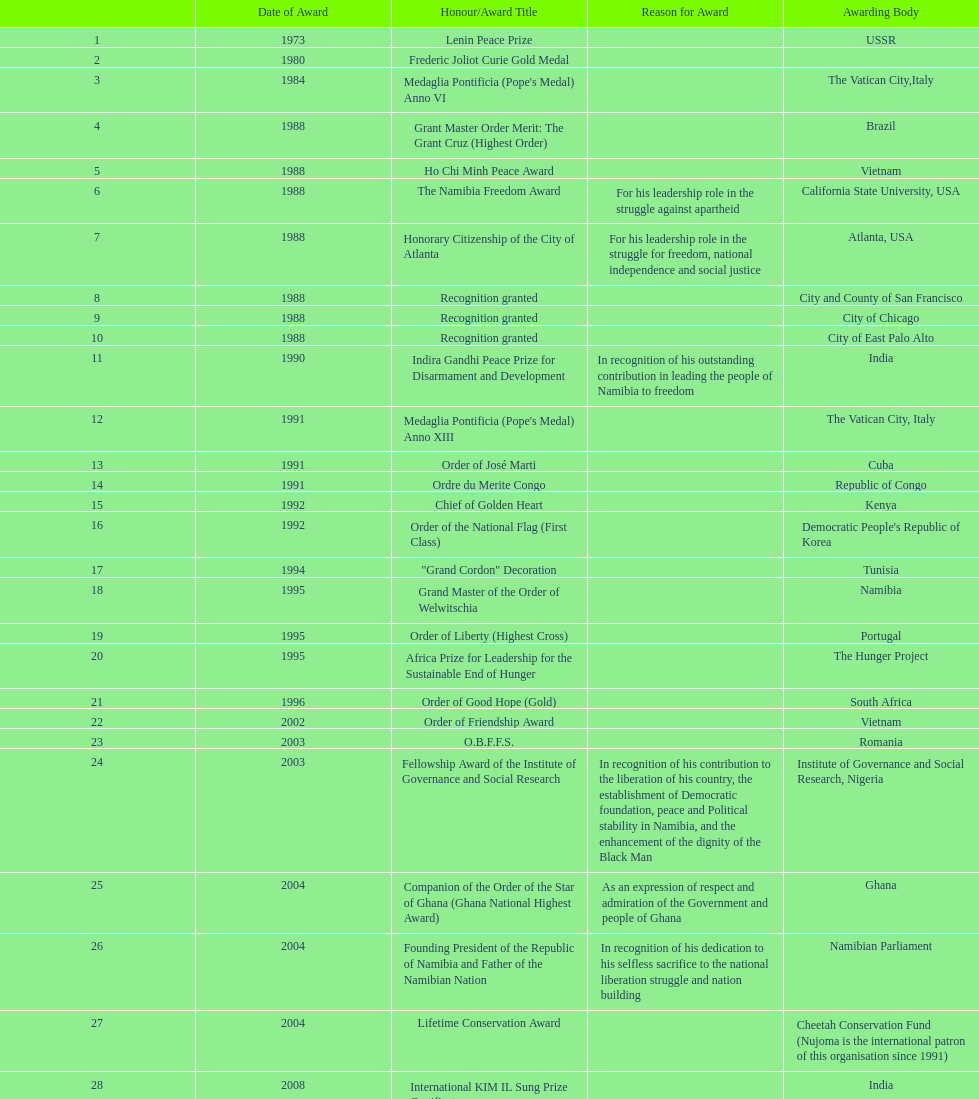In which year were the most accolades/award titles bestowed? 1988. 